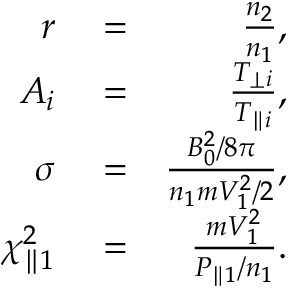<formula> <loc_0><loc_0><loc_500><loc_500>\begin{array} { r l r } { r } & = } & { \frac { n _ { 2 } } { n _ { 1 } } , } \\ { A _ { i } } & = } & { \frac { T _ { \perp i } } { T _ { \| i } } , } \\ { \sigma } & = } & { \frac { B _ { 0 } ^ { 2 } / 8 \pi } { n _ { 1 } m V _ { 1 } ^ { 2 } / 2 } , } \\ { \chi _ { \| 1 } ^ { 2 } } & = } & { \frac { m V _ { 1 } ^ { 2 } } { P _ { \| 1 } / n _ { 1 } } . } \end{array}</formula> 